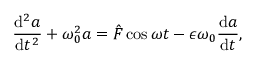<formula> <loc_0><loc_0><loc_500><loc_500>\frac { d ^ { 2 } a } { d t ^ { 2 } } + \omega _ { 0 } ^ { 2 } a = \hat { F } \cos \omega t - \epsilon \omega _ { 0 } \frac { d a } { d t } ,</formula> 